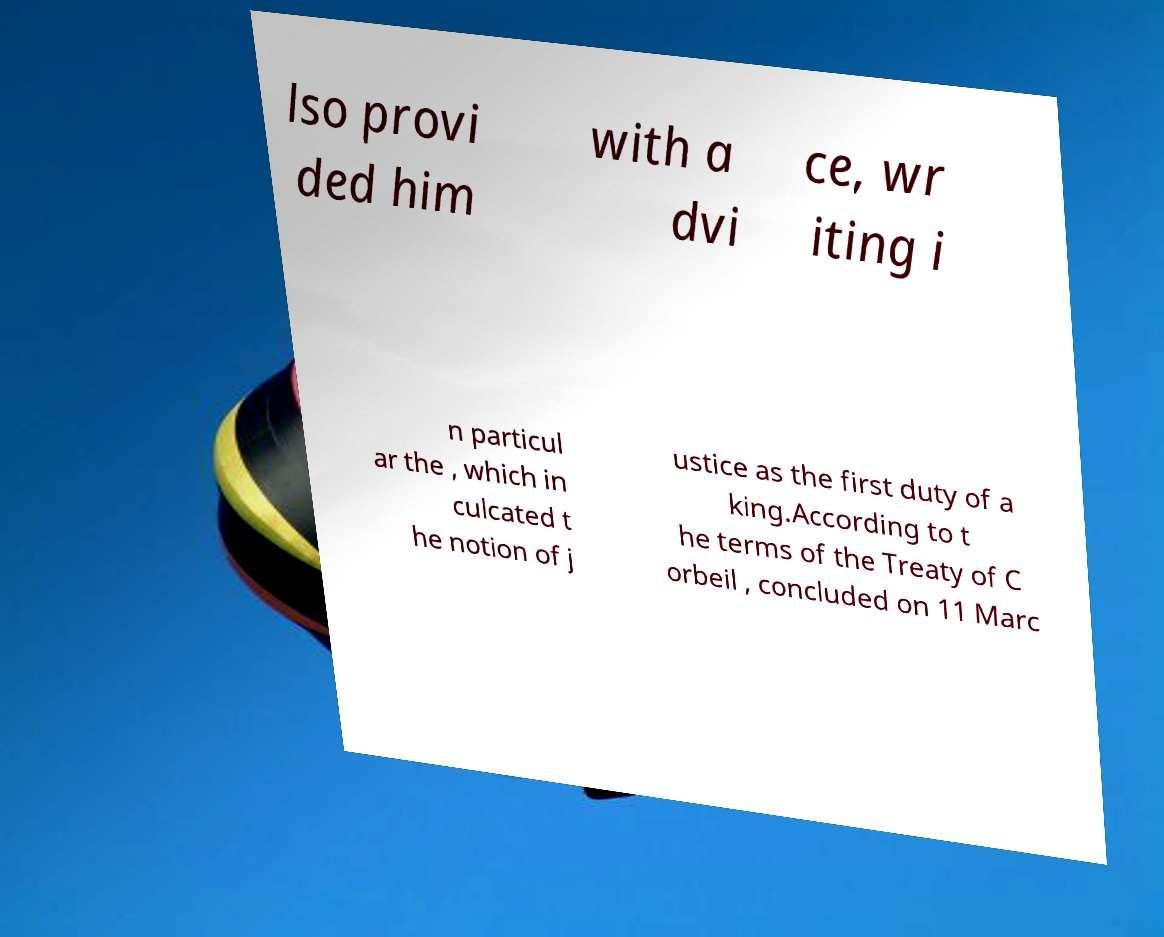Please identify and transcribe the text found in this image. lso provi ded him with a dvi ce, wr iting i n particul ar the , which in culcated t he notion of j ustice as the first duty of a king.According to t he terms of the Treaty of C orbeil , concluded on 11 Marc 